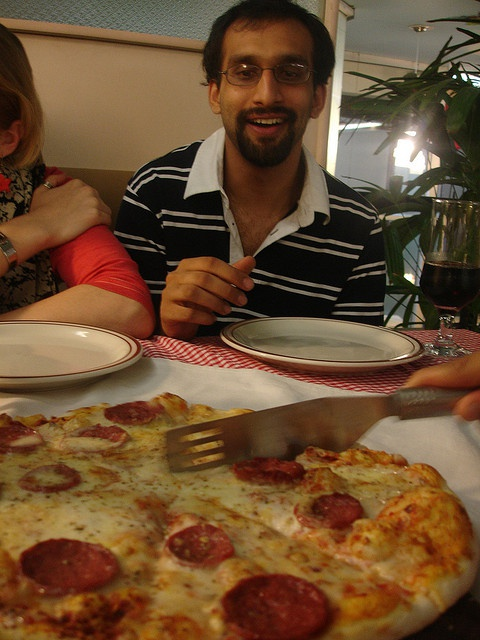Describe the objects in this image and their specific colors. I can see pizza in gray, olive, and maroon tones, people in gray, black, maroon, and brown tones, people in gray, black, maroon, and brown tones, potted plant in gray, black, darkgreen, and darkgray tones, and fork in gray, maroon, black, and olive tones in this image. 